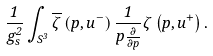Convert formula to latex. <formula><loc_0><loc_0><loc_500><loc_500>\frac { 1 } { g _ { s } ^ { 2 } } \int _ { S ^ { 3 } } \overline { \zeta } \left ( p , u ^ { - } \right ) \frac { 1 } { p \frac { \partial } { \partial p } } \zeta \left ( p , u ^ { + } \right ) .</formula> 